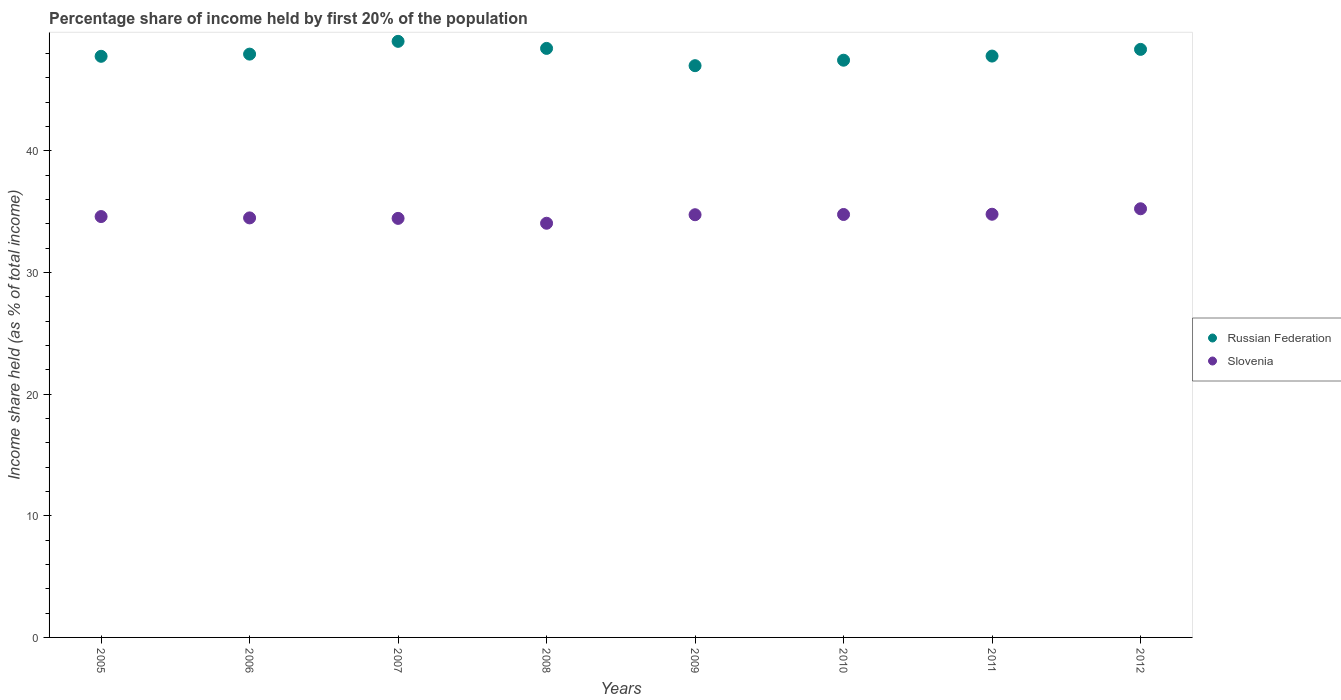Is the number of dotlines equal to the number of legend labels?
Make the answer very short. Yes. What is the share of income held by first 20% of the population in Russian Federation in 2011?
Make the answer very short. 47.78. Across all years, what is the maximum share of income held by first 20% of the population in Russian Federation?
Your response must be concise. 48.99. Across all years, what is the minimum share of income held by first 20% of the population in Russian Federation?
Provide a short and direct response. 46.99. In which year was the share of income held by first 20% of the population in Slovenia maximum?
Your answer should be compact. 2012. What is the total share of income held by first 20% of the population in Russian Federation in the graph?
Your answer should be compact. 383.64. What is the difference between the share of income held by first 20% of the population in Russian Federation in 2009 and that in 2010?
Your answer should be compact. -0.45. What is the difference between the share of income held by first 20% of the population in Slovenia in 2012 and the share of income held by first 20% of the population in Russian Federation in 2010?
Ensure brevity in your answer.  -12.21. What is the average share of income held by first 20% of the population in Russian Federation per year?
Make the answer very short. 47.95. In the year 2012, what is the difference between the share of income held by first 20% of the population in Russian Federation and share of income held by first 20% of the population in Slovenia?
Provide a succinct answer. 13.1. What is the ratio of the share of income held by first 20% of the population in Slovenia in 2005 to that in 2009?
Make the answer very short. 1. Is the share of income held by first 20% of the population in Slovenia in 2006 less than that in 2012?
Provide a succinct answer. Yes. Is the difference between the share of income held by first 20% of the population in Russian Federation in 2007 and 2012 greater than the difference between the share of income held by first 20% of the population in Slovenia in 2007 and 2012?
Give a very brief answer. Yes. What is the difference between the highest and the second highest share of income held by first 20% of the population in Russian Federation?
Provide a short and direct response. 0.58. In how many years, is the share of income held by first 20% of the population in Russian Federation greater than the average share of income held by first 20% of the population in Russian Federation taken over all years?
Provide a succinct answer. 3. Is the sum of the share of income held by first 20% of the population in Russian Federation in 2006 and 2007 greater than the maximum share of income held by first 20% of the population in Slovenia across all years?
Give a very brief answer. Yes. Does the share of income held by first 20% of the population in Slovenia monotonically increase over the years?
Ensure brevity in your answer.  No. Is the share of income held by first 20% of the population in Russian Federation strictly less than the share of income held by first 20% of the population in Slovenia over the years?
Make the answer very short. No. How many years are there in the graph?
Keep it short and to the point. 8. What is the difference between two consecutive major ticks on the Y-axis?
Give a very brief answer. 10. Are the values on the major ticks of Y-axis written in scientific E-notation?
Your answer should be very brief. No. Does the graph contain any zero values?
Offer a very short reply. No. Does the graph contain grids?
Your response must be concise. No. Where does the legend appear in the graph?
Offer a very short reply. Center right. How are the legend labels stacked?
Give a very brief answer. Vertical. What is the title of the graph?
Provide a succinct answer. Percentage share of income held by first 20% of the population. What is the label or title of the Y-axis?
Your answer should be very brief. Income share held (as % of total income). What is the Income share held (as % of total income) in Russian Federation in 2005?
Your answer should be compact. 47.76. What is the Income share held (as % of total income) in Slovenia in 2005?
Your answer should be compact. 34.59. What is the Income share held (as % of total income) in Russian Federation in 2006?
Provide a succinct answer. 47.94. What is the Income share held (as % of total income) in Slovenia in 2006?
Ensure brevity in your answer.  34.48. What is the Income share held (as % of total income) of Russian Federation in 2007?
Offer a terse response. 48.99. What is the Income share held (as % of total income) of Slovenia in 2007?
Offer a very short reply. 34.44. What is the Income share held (as % of total income) of Russian Federation in 2008?
Give a very brief answer. 48.41. What is the Income share held (as % of total income) in Slovenia in 2008?
Provide a short and direct response. 34.04. What is the Income share held (as % of total income) of Russian Federation in 2009?
Provide a succinct answer. 46.99. What is the Income share held (as % of total income) in Slovenia in 2009?
Your answer should be very brief. 34.74. What is the Income share held (as % of total income) in Russian Federation in 2010?
Your answer should be very brief. 47.44. What is the Income share held (as % of total income) of Slovenia in 2010?
Make the answer very short. 34.76. What is the Income share held (as % of total income) of Russian Federation in 2011?
Provide a succinct answer. 47.78. What is the Income share held (as % of total income) of Slovenia in 2011?
Your answer should be compact. 34.78. What is the Income share held (as % of total income) of Russian Federation in 2012?
Give a very brief answer. 48.33. What is the Income share held (as % of total income) in Slovenia in 2012?
Provide a short and direct response. 35.23. Across all years, what is the maximum Income share held (as % of total income) in Russian Federation?
Your answer should be very brief. 48.99. Across all years, what is the maximum Income share held (as % of total income) in Slovenia?
Offer a very short reply. 35.23. Across all years, what is the minimum Income share held (as % of total income) in Russian Federation?
Ensure brevity in your answer.  46.99. Across all years, what is the minimum Income share held (as % of total income) of Slovenia?
Your answer should be very brief. 34.04. What is the total Income share held (as % of total income) of Russian Federation in the graph?
Make the answer very short. 383.64. What is the total Income share held (as % of total income) in Slovenia in the graph?
Your answer should be very brief. 277.06. What is the difference between the Income share held (as % of total income) of Russian Federation in 2005 and that in 2006?
Ensure brevity in your answer.  -0.18. What is the difference between the Income share held (as % of total income) in Slovenia in 2005 and that in 2006?
Ensure brevity in your answer.  0.11. What is the difference between the Income share held (as % of total income) in Russian Federation in 2005 and that in 2007?
Provide a short and direct response. -1.23. What is the difference between the Income share held (as % of total income) of Slovenia in 2005 and that in 2007?
Make the answer very short. 0.15. What is the difference between the Income share held (as % of total income) of Russian Federation in 2005 and that in 2008?
Offer a very short reply. -0.65. What is the difference between the Income share held (as % of total income) of Slovenia in 2005 and that in 2008?
Make the answer very short. 0.55. What is the difference between the Income share held (as % of total income) in Russian Federation in 2005 and that in 2009?
Give a very brief answer. 0.77. What is the difference between the Income share held (as % of total income) of Russian Federation in 2005 and that in 2010?
Your response must be concise. 0.32. What is the difference between the Income share held (as % of total income) in Slovenia in 2005 and that in 2010?
Make the answer very short. -0.17. What is the difference between the Income share held (as % of total income) of Russian Federation in 2005 and that in 2011?
Give a very brief answer. -0.02. What is the difference between the Income share held (as % of total income) of Slovenia in 2005 and that in 2011?
Provide a short and direct response. -0.19. What is the difference between the Income share held (as % of total income) of Russian Federation in 2005 and that in 2012?
Your answer should be compact. -0.57. What is the difference between the Income share held (as % of total income) of Slovenia in 2005 and that in 2012?
Provide a succinct answer. -0.64. What is the difference between the Income share held (as % of total income) of Russian Federation in 2006 and that in 2007?
Ensure brevity in your answer.  -1.05. What is the difference between the Income share held (as % of total income) in Slovenia in 2006 and that in 2007?
Provide a succinct answer. 0.04. What is the difference between the Income share held (as % of total income) in Russian Federation in 2006 and that in 2008?
Offer a very short reply. -0.47. What is the difference between the Income share held (as % of total income) of Slovenia in 2006 and that in 2008?
Provide a short and direct response. 0.44. What is the difference between the Income share held (as % of total income) in Slovenia in 2006 and that in 2009?
Keep it short and to the point. -0.26. What is the difference between the Income share held (as % of total income) of Russian Federation in 2006 and that in 2010?
Ensure brevity in your answer.  0.5. What is the difference between the Income share held (as % of total income) in Slovenia in 2006 and that in 2010?
Your answer should be very brief. -0.28. What is the difference between the Income share held (as % of total income) of Russian Federation in 2006 and that in 2011?
Give a very brief answer. 0.16. What is the difference between the Income share held (as % of total income) in Russian Federation in 2006 and that in 2012?
Your response must be concise. -0.39. What is the difference between the Income share held (as % of total income) of Slovenia in 2006 and that in 2012?
Your answer should be compact. -0.75. What is the difference between the Income share held (as % of total income) of Russian Federation in 2007 and that in 2008?
Give a very brief answer. 0.58. What is the difference between the Income share held (as % of total income) of Russian Federation in 2007 and that in 2010?
Your answer should be very brief. 1.55. What is the difference between the Income share held (as % of total income) in Slovenia in 2007 and that in 2010?
Your response must be concise. -0.32. What is the difference between the Income share held (as % of total income) of Russian Federation in 2007 and that in 2011?
Your answer should be very brief. 1.21. What is the difference between the Income share held (as % of total income) of Slovenia in 2007 and that in 2011?
Make the answer very short. -0.34. What is the difference between the Income share held (as % of total income) of Russian Federation in 2007 and that in 2012?
Offer a terse response. 0.66. What is the difference between the Income share held (as % of total income) of Slovenia in 2007 and that in 2012?
Your response must be concise. -0.79. What is the difference between the Income share held (as % of total income) of Russian Federation in 2008 and that in 2009?
Ensure brevity in your answer.  1.42. What is the difference between the Income share held (as % of total income) in Russian Federation in 2008 and that in 2010?
Ensure brevity in your answer.  0.97. What is the difference between the Income share held (as % of total income) of Slovenia in 2008 and that in 2010?
Offer a terse response. -0.72. What is the difference between the Income share held (as % of total income) of Russian Federation in 2008 and that in 2011?
Make the answer very short. 0.63. What is the difference between the Income share held (as % of total income) in Slovenia in 2008 and that in 2011?
Keep it short and to the point. -0.74. What is the difference between the Income share held (as % of total income) in Slovenia in 2008 and that in 2012?
Make the answer very short. -1.19. What is the difference between the Income share held (as % of total income) of Russian Federation in 2009 and that in 2010?
Provide a short and direct response. -0.45. What is the difference between the Income share held (as % of total income) in Slovenia in 2009 and that in 2010?
Provide a succinct answer. -0.02. What is the difference between the Income share held (as % of total income) of Russian Federation in 2009 and that in 2011?
Your answer should be compact. -0.79. What is the difference between the Income share held (as % of total income) in Slovenia in 2009 and that in 2011?
Your answer should be compact. -0.04. What is the difference between the Income share held (as % of total income) of Russian Federation in 2009 and that in 2012?
Provide a succinct answer. -1.34. What is the difference between the Income share held (as % of total income) in Slovenia in 2009 and that in 2012?
Your answer should be very brief. -0.49. What is the difference between the Income share held (as % of total income) in Russian Federation in 2010 and that in 2011?
Ensure brevity in your answer.  -0.34. What is the difference between the Income share held (as % of total income) of Slovenia in 2010 and that in 2011?
Ensure brevity in your answer.  -0.02. What is the difference between the Income share held (as % of total income) of Russian Federation in 2010 and that in 2012?
Your answer should be compact. -0.89. What is the difference between the Income share held (as % of total income) in Slovenia in 2010 and that in 2012?
Offer a terse response. -0.47. What is the difference between the Income share held (as % of total income) of Russian Federation in 2011 and that in 2012?
Your answer should be very brief. -0.55. What is the difference between the Income share held (as % of total income) in Slovenia in 2011 and that in 2012?
Keep it short and to the point. -0.45. What is the difference between the Income share held (as % of total income) of Russian Federation in 2005 and the Income share held (as % of total income) of Slovenia in 2006?
Give a very brief answer. 13.28. What is the difference between the Income share held (as % of total income) in Russian Federation in 2005 and the Income share held (as % of total income) in Slovenia in 2007?
Your answer should be compact. 13.32. What is the difference between the Income share held (as % of total income) of Russian Federation in 2005 and the Income share held (as % of total income) of Slovenia in 2008?
Your response must be concise. 13.72. What is the difference between the Income share held (as % of total income) in Russian Federation in 2005 and the Income share held (as % of total income) in Slovenia in 2009?
Offer a very short reply. 13.02. What is the difference between the Income share held (as % of total income) in Russian Federation in 2005 and the Income share held (as % of total income) in Slovenia in 2011?
Your answer should be very brief. 12.98. What is the difference between the Income share held (as % of total income) in Russian Federation in 2005 and the Income share held (as % of total income) in Slovenia in 2012?
Give a very brief answer. 12.53. What is the difference between the Income share held (as % of total income) of Russian Federation in 2006 and the Income share held (as % of total income) of Slovenia in 2008?
Ensure brevity in your answer.  13.9. What is the difference between the Income share held (as % of total income) in Russian Federation in 2006 and the Income share held (as % of total income) in Slovenia in 2010?
Ensure brevity in your answer.  13.18. What is the difference between the Income share held (as % of total income) in Russian Federation in 2006 and the Income share held (as % of total income) in Slovenia in 2011?
Your response must be concise. 13.16. What is the difference between the Income share held (as % of total income) of Russian Federation in 2006 and the Income share held (as % of total income) of Slovenia in 2012?
Offer a terse response. 12.71. What is the difference between the Income share held (as % of total income) in Russian Federation in 2007 and the Income share held (as % of total income) in Slovenia in 2008?
Make the answer very short. 14.95. What is the difference between the Income share held (as % of total income) of Russian Federation in 2007 and the Income share held (as % of total income) of Slovenia in 2009?
Keep it short and to the point. 14.25. What is the difference between the Income share held (as % of total income) of Russian Federation in 2007 and the Income share held (as % of total income) of Slovenia in 2010?
Your response must be concise. 14.23. What is the difference between the Income share held (as % of total income) in Russian Federation in 2007 and the Income share held (as % of total income) in Slovenia in 2011?
Give a very brief answer. 14.21. What is the difference between the Income share held (as % of total income) in Russian Federation in 2007 and the Income share held (as % of total income) in Slovenia in 2012?
Your response must be concise. 13.76. What is the difference between the Income share held (as % of total income) in Russian Federation in 2008 and the Income share held (as % of total income) in Slovenia in 2009?
Make the answer very short. 13.67. What is the difference between the Income share held (as % of total income) of Russian Federation in 2008 and the Income share held (as % of total income) of Slovenia in 2010?
Make the answer very short. 13.65. What is the difference between the Income share held (as % of total income) of Russian Federation in 2008 and the Income share held (as % of total income) of Slovenia in 2011?
Your answer should be very brief. 13.63. What is the difference between the Income share held (as % of total income) in Russian Federation in 2008 and the Income share held (as % of total income) in Slovenia in 2012?
Your answer should be very brief. 13.18. What is the difference between the Income share held (as % of total income) of Russian Federation in 2009 and the Income share held (as % of total income) of Slovenia in 2010?
Your answer should be compact. 12.23. What is the difference between the Income share held (as % of total income) in Russian Federation in 2009 and the Income share held (as % of total income) in Slovenia in 2011?
Ensure brevity in your answer.  12.21. What is the difference between the Income share held (as % of total income) in Russian Federation in 2009 and the Income share held (as % of total income) in Slovenia in 2012?
Offer a very short reply. 11.76. What is the difference between the Income share held (as % of total income) in Russian Federation in 2010 and the Income share held (as % of total income) in Slovenia in 2011?
Offer a very short reply. 12.66. What is the difference between the Income share held (as % of total income) in Russian Federation in 2010 and the Income share held (as % of total income) in Slovenia in 2012?
Your response must be concise. 12.21. What is the difference between the Income share held (as % of total income) of Russian Federation in 2011 and the Income share held (as % of total income) of Slovenia in 2012?
Your response must be concise. 12.55. What is the average Income share held (as % of total income) of Russian Federation per year?
Provide a succinct answer. 47.95. What is the average Income share held (as % of total income) of Slovenia per year?
Provide a succinct answer. 34.63. In the year 2005, what is the difference between the Income share held (as % of total income) of Russian Federation and Income share held (as % of total income) of Slovenia?
Your answer should be very brief. 13.17. In the year 2006, what is the difference between the Income share held (as % of total income) in Russian Federation and Income share held (as % of total income) in Slovenia?
Your answer should be compact. 13.46. In the year 2007, what is the difference between the Income share held (as % of total income) in Russian Federation and Income share held (as % of total income) in Slovenia?
Your answer should be very brief. 14.55. In the year 2008, what is the difference between the Income share held (as % of total income) of Russian Federation and Income share held (as % of total income) of Slovenia?
Your answer should be very brief. 14.37. In the year 2009, what is the difference between the Income share held (as % of total income) of Russian Federation and Income share held (as % of total income) of Slovenia?
Your answer should be compact. 12.25. In the year 2010, what is the difference between the Income share held (as % of total income) of Russian Federation and Income share held (as % of total income) of Slovenia?
Your answer should be very brief. 12.68. In the year 2012, what is the difference between the Income share held (as % of total income) in Russian Federation and Income share held (as % of total income) in Slovenia?
Keep it short and to the point. 13.1. What is the ratio of the Income share held (as % of total income) of Russian Federation in 2005 to that in 2006?
Give a very brief answer. 1. What is the ratio of the Income share held (as % of total income) of Russian Federation in 2005 to that in 2007?
Your response must be concise. 0.97. What is the ratio of the Income share held (as % of total income) in Slovenia in 2005 to that in 2007?
Provide a succinct answer. 1. What is the ratio of the Income share held (as % of total income) of Russian Federation in 2005 to that in 2008?
Make the answer very short. 0.99. What is the ratio of the Income share held (as % of total income) in Slovenia in 2005 to that in 2008?
Keep it short and to the point. 1.02. What is the ratio of the Income share held (as % of total income) of Russian Federation in 2005 to that in 2009?
Your answer should be compact. 1.02. What is the ratio of the Income share held (as % of total income) in Slovenia in 2005 to that in 2009?
Offer a terse response. 1. What is the ratio of the Income share held (as % of total income) in Russian Federation in 2005 to that in 2010?
Give a very brief answer. 1.01. What is the ratio of the Income share held (as % of total income) of Russian Federation in 2005 to that in 2011?
Provide a short and direct response. 1. What is the ratio of the Income share held (as % of total income) in Slovenia in 2005 to that in 2011?
Your answer should be very brief. 0.99. What is the ratio of the Income share held (as % of total income) of Slovenia in 2005 to that in 2012?
Ensure brevity in your answer.  0.98. What is the ratio of the Income share held (as % of total income) of Russian Federation in 2006 to that in 2007?
Keep it short and to the point. 0.98. What is the ratio of the Income share held (as % of total income) in Russian Federation in 2006 to that in 2008?
Provide a succinct answer. 0.99. What is the ratio of the Income share held (as % of total income) of Slovenia in 2006 to that in 2008?
Make the answer very short. 1.01. What is the ratio of the Income share held (as % of total income) in Russian Federation in 2006 to that in 2009?
Provide a succinct answer. 1.02. What is the ratio of the Income share held (as % of total income) in Russian Federation in 2006 to that in 2010?
Provide a short and direct response. 1.01. What is the ratio of the Income share held (as % of total income) in Slovenia in 2006 to that in 2010?
Keep it short and to the point. 0.99. What is the ratio of the Income share held (as % of total income) of Russian Federation in 2006 to that in 2011?
Give a very brief answer. 1. What is the ratio of the Income share held (as % of total income) in Slovenia in 2006 to that in 2011?
Offer a terse response. 0.99. What is the ratio of the Income share held (as % of total income) of Slovenia in 2006 to that in 2012?
Your answer should be compact. 0.98. What is the ratio of the Income share held (as % of total income) in Slovenia in 2007 to that in 2008?
Offer a terse response. 1.01. What is the ratio of the Income share held (as % of total income) in Russian Federation in 2007 to that in 2009?
Your response must be concise. 1.04. What is the ratio of the Income share held (as % of total income) in Russian Federation in 2007 to that in 2010?
Your answer should be compact. 1.03. What is the ratio of the Income share held (as % of total income) in Slovenia in 2007 to that in 2010?
Your response must be concise. 0.99. What is the ratio of the Income share held (as % of total income) of Russian Federation in 2007 to that in 2011?
Provide a short and direct response. 1.03. What is the ratio of the Income share held (as % of total income) in Slovenia in 2007 to that in 2011?
Provide a succinct answer. 0.99. What is the ratio of the Income share held (as % of total income) in Russian Federation in 2007 to that in 2012?
Provide a succinct answer. 1.01. What is the ratio of the Income share held (as % of total income) of Slovenia in 2007 to that in 2012?
Provide a short and direct response. 0.98. What is the ratio of the Income share held (as % of total income) in Russian Federation in 2008 to that in 2009?
Give a very brief answer. 1.03. What is the ratio of the Income share held (as % of total income) in Slovenia in 2008 to that in 2009?
Your answer should be very brief. 0.98. What is the ratio of the Income share held (as % of total income) in Russian Federation in 2008 to that in 2010?
Offer a very short reply. 1.02. What is the ratio of the Income share held (as % of total income) of Slovenia in 2008 to that in 2010?
Your answer should be compact. 0.98. What is the ratio of the Income share held (as % of total income) of Russian Federation in 2008 to that in 2011?
Your response must be concise. 1.01. What is the ratio of the Income share held (as % of total income) of Slovenia in 2008 to that in 2011?
Give a very brief answer. 0.98. What is the ratio of the Income share held (as % of total income) in Slovenia in 2008 to that in 2012?
Offer a terse response. 0.97. What is the ratio of the Income share held (as % of total income) in Russian Federation in 2009 to that in 2010?
Offer a terse response. 0.99. What is the ratio of the Income share held (as % of total income) of Russian Federation in 2009 to that in 2011?
Make the answer very short. 0.98. What is the ratio of the Income share held (as % of total income) in Russian Federation in 2009 to that in 2012?
Provide a succinct answer. 0.97. What is the ratio of the Income share held (as % of total income) in Slovenia in 2009 to that in 2012?
Your response must be concise. 0.99. What is the ratio of the Income share held (as % of total income) in Slovenia in 2010 to that in 2011?
Give a very brief answer. 1. What is the ratio of the Income share held (as % of total income) of Russian Federation in 2010 to that in 2012?
Give a very brief answer. 0.98. What is the ratio of the Income share held (as % of total income) of Slovenia in 2010 to that in 2012?
Ensure brevity in your answer.  0.99. What is the ratio of the Income share held (as % of total income) in Slovenia in 2011 to that in 2012?
Give a very brief answer. 0.99. What is the difference between the highest and the second highest Income share held (as % of total income) of Russian Federation?
Give a very brief answer. 0.58. What is the difference between the highest and the second highest Income share held (as % of total income) in Slovenia?
Offer a very short reply. 0.45. What is the difference between the highest and the lowest Income share held (as % of total income) in Slovenia?
Offer a terse response. 1.19. 